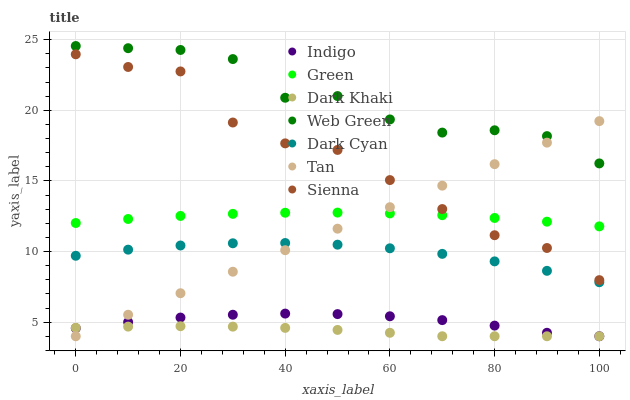Does Dark Khaki have the minimum area under the curve?
Answer yes or no. Yes. Does Web Green have the maximum area under the curve?
Answer yes or no. Yes. Does Indigo have the minimum area under the curve?
Answer yes or no. No. Does Indigo have the maximum area under the curve?
Answer yes or no. No. Is Tan the smoothest?
Answer yes or no. Yes. Is Sienna the roughest?
Answer yes or no. Yes. Is Indigo the smoothest?
Answer yes or no. No. Is Indigo the roughest?
Answer yes or no. No. Does Indigo have the lowest value?
Answer yes or no. Yes. Does Web Green have the lowest value?
Answer yes or no. No. Does Web Green have the highest value?
Answer yes or no. Yes. Does Indigo have the highest value?
Answer yes or no. No. Is Indigo less than Sienna?
Answer yes or no. Yes. Is Dark Cyan greater than Indigo?
Answer yes or no. Yes. Does Green intersect Sienna?
Answer yes or no. Yes. Is Green less than Sienna?
Answer yes or no. No. Is Green greater than Sienna?
Answer yes or no. No. Does Indigo intersect Sienna?
Answer yes or no. No. 